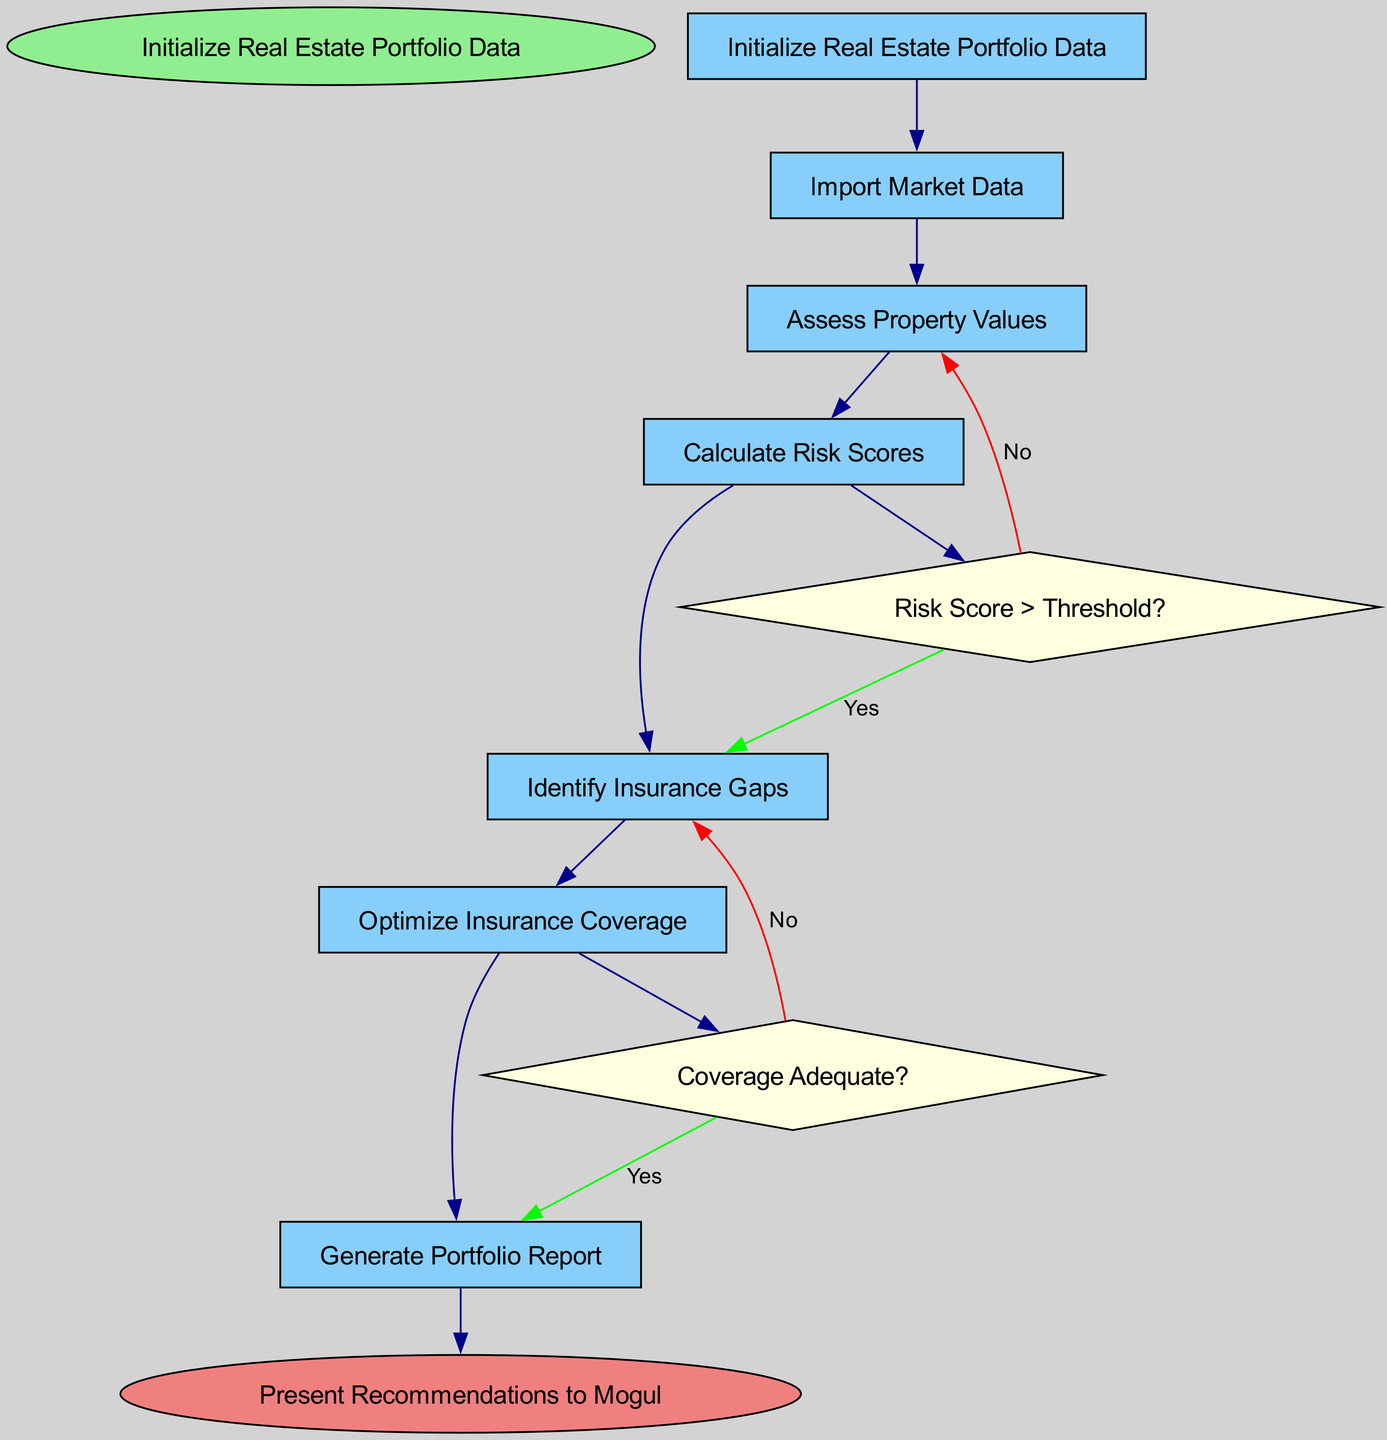What is the starting point of the flowchart? The flowchart begins with the node labeled "Initialize Real Estate Portfolio Data," indicating that this is the initial step in the process.
Answer: Initialize Real Estate Portfolio Data How many nodes are present in the diagram? The flowchart contains a total of 7 nodes: 1 start node, 5 process nodes, 1 end node.
Answer: 7 What is the first node that follows "Import Market Data"? The next step after "Import Market Data" is "Assess Property Values," which directly follows this node in the flowchart.
Answer: Assess Property Values What is the decision condition for "Calculate Risk Scores"? The decision following "Calculate Risk Scores" is based on the condition "Risk Score > Threshold?". This condition determines the next step in the process.
Answer: Risk Score > Threshold? Which node does "Identify Insurance Gaps" lead to if the coverage is not adequate? If the coverage is determined to be inadequate from the "Optimize Insurance Coverage" node, the process flows back to "Identify Insurance Gaps." This is the direct consequence of the "No" outcome from this decision point.
Answer: Identify Insurance Gaps What color is used for the end node? The end node, labeled "Present Recommendations to Mogul," is colored light coral according to the diagram's specifications for end nodes.
Answer: Light coral What is the last step before generating the portfolio report? The final step before "Generate Portfolio Report" is "Optimize Insurance Coverage," indicating that this process must be completed first.
Answer: Optimize Insurance Coverage What happens if "Risk Score" does not exceed the threshold? If the "Risk Score" is not greater than the threshold, the flowchart indicates that the process returns to "Assess Property Values," demonstrating an iterative evaluation methodology.
Answer: Assess Property Values How many edges connect the nodes in the flowchart? There are six edges connecting the nodes, representing the flow from one node to another without any skipped connections.
Answer: 6 